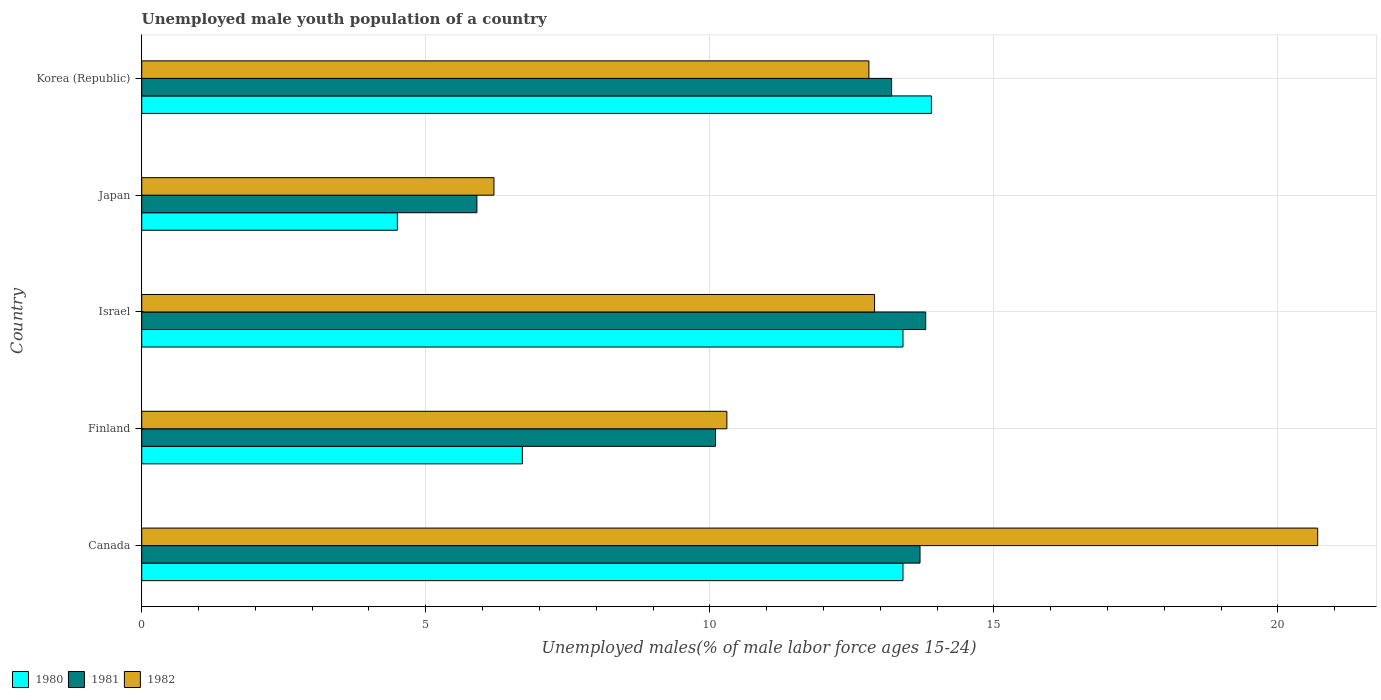How many different coloured bars are there?
Your response must be concise. 3. How many groups of bars are there?
Offer a terse response. 5. Are the number of bars on each tick of the Y-axis equal?
Offer a terse response. Yes. What is the label of the 4th group of bars from the top?
Provide a succinct answer. Finland. What is the percentage of unemployed male youth population in 1980 in Japan?
Your response must be concise. 4.5. Across all countries, what is the maximum percentage of unemployed male youth population in 1981?
Keep it short and to the point. 13.8. Across all countries, what is the minimum percentage of unemployed male youth population in 1982?
Your response must be concise. 6.2. In which country was the percentage of unemployed male youth population in 1982 minimum?
Your answer should be compact. Japan. What is the total percentage of unemployed male youth population in 1980 in the graph?
Your answer should be very brief. 51.9. What is the difference between the percentage of unemployed male youth population in 1982 in Canada and that in Korea (Republic)?
Your answer should be compact. 7.9. What is the difference between the percentage of unemployed male youth population in 1982 in Japan and the percentage of unemployed male youth population in 1981 in Canada?
Offer a terse response. -7.5. What is the average percentage of unemployed male youth population in 1982 per country?
Provide a short and direct response. 12.58. What is the difference between the percentage of unemployed male youth population in 1981 and percentage of unemployed male youth population in 1980 in Canada?
Keep it short and to the point. 0.3. What is the ratio of the percentage of unemployed male youth population in 1981 in Canada to that in Japan?
Provide a short and direct response. 2.32. Is the percentage of unemployed male youth population in 1981 in Finland less than that in Korea (Republic)?
Make the answer very short. Yes. What is the difference between the highest and the second highest percentage of unemployed male youth population in 1982?
Offer a terse response. 7.8. What is the difference between the highest and the lowest percentage of unemployed male youth population in 1981?
Offer a terse response. 7.9. What does the 2nd bar from the top in Israel represents?
Give a very brief answer. 1981. What does the 3rd bar from the bottom in Canada represents?
Your answer should be very brief. 1982. How many bars are there?
Keep it short and to the point. 15. Are all the bars in the graph horizontal?
Your answer should be very brief. Yes. Are the values on the major ticks of X-axis written in scientific E-notation?
Ensure brevity in your answer.  No. Does the graph contain any zero values?
Offer a very short reply. No. What is the title of the graph?
Keep it short and to the point. Unemployed male youth population of a country. What is the label or title of the X-axis?
Make the answer very short. Unemployed males(% of male labor force ages 15-24). What is the Unemployed males(% of male labor force ages 15-24) in 1980 in Canada?
Keep it short and to the point. 13.4. What is the Unemployed males(% of male labor force ages 15-24) of 1981 in Canada?
Offer a very short reply. 13.7. What is the Unemployed males(% of male labor force ages 15-24) of 1982 in Canada?
Your answer should be compact. 20.7. What is the Unemployed males(% of male labor force ages 15-24) of 1980 in Finland?
Your answer should be very brief. 6.7. What is the Unemployed males(% of male labor force ages 15-24) in 1981 in Finland?
Make the answer very short. 10.1. What is the Unemployed males(% of male labor force ages 15-24) in 1982 in Finland?
Give a very brief answer. 10.3. What is the Unemployed males(% of male labor force ages 15-24) of 1980 in Israel?
Provide a succinct answer. 13.4. What is the Unemployed males(% of male labor force ages 15-24) in 1981 in Israel?
Keep it short and to the point. 13.8. What is the Unemployed males(% of male labor force ages 15-24) of 1982 in Israel?
Keep it short and to the point. 12.9. What is the Unemployed males(% of male labor force ages 15-24) of 1981 in Japan?
Make the answer very short. 5.9. What is the Unemployed males(% of male labor force ages 15-24) of 1982 in Japan?
Provide a succinct answer. 6.2. What is the Unemployed males(% of male labor force ages 15-24) in 1980 in Korea (Republic)?
Your answer should be compact. 13.9. What is the Unemployed males(% of male labor force ages 15-24) of 1981 in Korea (Republic)?
Ensure brevity in your answer.  13.2. What is the Unemployed males(% of male labor force ages 15-24) in 1982 in Korea (Republic)?
Provide a short and direct response. 12.8. Across all countries, what is the maximum Unemployed males(% of male labor force ages 15-24) of 1980?
Your response must be concise. 13.9. Across all countries, what is the maximum Unemployed males(% of male labor force ages 15-24) in 1981?
Provide a short and direct response. 13.8. Across all countries, what is the maximum Unemployed males(% of male labor force ages 15-24) of 1982?
Ensure brevity in your answer.  20.7. Across all countries, what is the minimum Unemployed males(% of male labor force ages 15-24) in 1981?
Give a very brief answer. 5.9. Across all countries, what is the minimum Unemployed males(% of male labor force ages 15-24) in 1982?
Ensure brevity in your answer.  6.2. What is the total Unemployed males(% of male labor force ages 15-24) of 1980 in the graph?
Keep it short and to the point. 51.9. What is the total Unemployed males(% of male labor force ages 15-24) of 1981 in the graph?
Ensure brevity in your answer.  56.7. What is the total Unemployed males(% of male labor force ages 15-24) of 1982 in the graph?
Your response must be concise. 62.9. What is the difference between the Unemployed males(% of male labor force ages 15-24) of 1980 in Canada and that in Finland?
Your answer should be very brief. 6.7. What is the difference between the Unemployed males(% of male labor force ages 15-24) in 1982 in Canada and that in Finland?
Make the answer very short. 10.4. What is the difference between the Unemployed males(% of male labor force ages 15-24) in 1981 in Canada and that in Israel?
Keep it short and to the point. -0.1. What is the difference between the Unemployed males(% of male labor force ages 15-24) in 1982 in Canada and that in Israel?
Your answer should be compact. 7.8. What is the difference between the Unemployed males(% of male labor force ages 15-24) in 1981 in Canada and that in Japan?
Your answer should be compact. 7.8. What is the difference between the Unemployed males(% of male labor force ages 15-24) in 1982 in Canada and that in Japan?
Your response must be concise. 14.5. What is the difference between the Unemployed males(% of male labor force ages 15-24) in 1980 in Finland and that in Israel?
Make the answer very short. -6.7. What is the difference between the Unemployed males(% of male labor force ages 15-24) of 1981 in Finland and that in Israel?
Provide a short and direct response. -3.7. What is the difference between the Unemployed males(% of male labor force ages 15-24) of 1980 in Finland and that in Japan?
Give a very brief answer. 2.2. What is the difference between the Unemployed males(% of male labor force ages 15-24) in 1981 in Finland and that in Japan?
Provide a short and direct response. 4.2. What is the difference between the Unemployed males(% of male labor force ages 15-24) in 1982 in Finland and that in Japan?
Offer a very short reply. 4.1. What is the difference between the Unemployed males(% of male labor force ages 15-24) in 1980 in Finland and that in Korea (Republic)?
Provide a succinct answer. -7.2. What is the difference between the Unemployed males(% of male labor force ages 15-24) of 1980 in Israel and that in Japan?
Ensure brevity in your answer.  8.9. What is the difference between the Unemployed males(% of male labor force ages 15-24) in 1981 in Israel and that in Japan?
Offer a very short reply. 7.9. What is the difference between the Unemployed males(% of male labor force ages 15-24) in 1982 in Israel and that in Japan?
Your answer should be very brief. 6.7. What is the difference between the Unemployed males(% of male labor force ages 15-24) of 1982 in Israel and that in Korea (Republic)?
Offer a terse response. 0.1. What is the difference between the Unemployed males(% of male labor force ages 15-24) in 1980 in Japan and that in Korea (Republic)?
Ensure brevity in your answer.  -9.4. What is the difference between the Unemployed males(% of male labor force ages 15-24) of 1982 in Japan and that in Korea (Republic)?
Make the answer very short. -6.6. What is the difference between the Unemployed males(% of male labor force ages 15-24) of 1980 in Canada and the Unemployed males(% of male labor force ages 15-24) of 1982 in Finland?
Your response must be concise. 3.1. What is the difference between the Unemployed males(% of male labor force ages 15-24) in 1981 in Canada and the Unemployed males(% of male labor force ages 15-24) in 1982 in Finland?
Ensure brevity in your answer.  3.4. What is the difference between the Unemployed males(% of male labor force ages 15-24) of 1980 in Canada and the Unemployed males(% of male labor force ages 15-24) of 1981 in Israel?
Offer a terse response. -0.4. What is the difference between the Unemployed males(% of male labor force ages 15-24) of 1981 in Canada and the Unemployed males(% of male labor force ages 15-24) of 1982 in Israel?
Your answer should be very brief. 0.8. What is the difference between the Unemployed males(% of male labor force ages 15-24) in 1980 in Canada and the Unemployed males(% of male labor force ages 15-24) in 1981 in Japan?
Provide a short and direct response. 7.5. What is the difference between the Unemployed males(% of male labor force ages 15-24) in 1980 in Canada and the Unemployed males(% of male labor force ages 15-24) in 1982 in Japan?
Make the answer very short. 7.2. What is the difference between the Unemployed males(% of male labor force ages 15-24) in 1980 in Canada and the Unemployed males(% of male labor force ages 15-24) in 1981 in Korea (Republic)?
Provide a succinct answer. 0.2. What is the difference between the Unemployed males(% of male labor force ages 15-24) of 1980 in Canada and the Unemployed males(% of male labor force ages 15-24) of 1982 in Korea (Republic)?
Ensure brevity in your answer.  0.6. What is the difference between the Unemployed males(% of male labor force ages 15-24) in 1981 in Canada and the Unemployed males(% of male labor force ages 15-24) in 1982 in Korea (Republic)?
Your answer should be very brief. 0.9. What is the difference between the Unemployed males(% of male labor force ages 15-24) in 1980 in Finland and the Unemployed males(% of male labor force ages 15-24) in 1981 in Japan?
Make the answer very short. 0.8. What is the difference between the Unemployed males(% of male labor force ages 15-24) of 1980 in Finland and the Unemployed males(% of male labor force ages 15-24) of 1982 in Japan?
Provide a succinct answer. 0.5. What is the difference between the Unemployed males(% of male labor force ages 15-24) of 1981 in Finland and the Unemployed males(% of male labor force ages 15-24) of 1982 in Japan?
Your response must be concise. 3.9. What is the difference between the Unemployed males(% of male labor force ages 15-24) of 1980 in Finland and the Unemployed males(% of male labor force ages 15-24) of 1981 in Korea (Republic)?
Give a very brief answer. -6.5. What is the difference between the Unemployed males(% of male labor force ages 15-24) in 1980 in Israel and the Unemployed males(% of male labor force ages 15-24) in 1981 in Japan?
Ensure brevity in your answer.  7.5. What is the difference between the Unemployed males(% of male labor force ages 15-24) of 1980 in Israel and the Unemployed males(% of male labor force ages 15-24) of 1981 in Korea (Republic)?
Keep it short and to the point. 0.2. What is the difference between the Unemployed males(% of male labor force ages 15-24) in 1980 in Israel and the Unemployed males(% of male labor force ages 15-24) in 1982 in Korea (Republic)?
Your response must be concise. 0.6. What is the difference between the Unemployed males(% of male labor force ages 15-24) in 1980 in Japan and the Unemployed males(% of male labor force ages 15-24) in 1981 in Korea (Republic)?
Offer a terse response. -8.7. What is the difference between the Unemployed males(% of male labor force ages 15-24) in 1980 in Japan and the Unemployed males(% of male labor force ages 15-24) in 1982 in Korea (Republic)?
Provide a succinct answer. -8.3. What is the average Unemployed males(% of male labor force ages 15-24) of 1980 per country?
Offer a terse response. 10.38. What is the average Unemployed males(% of male labor force ages 15-24) of 1981 per country?
Your answer should be compact. 11.34. What is the average Unemployed males(% of male labor force ages 15-24) of 1982 per country?
Your answer should be compact. 12.58. What is the difference between the Unemployed males(% of male labor force ages 15-24) of 1980 and Unemployed males(% of male labor force ages 15-24) of 1981 in Canada?
Your response must be concise. -0.3. What is the difference between the Unemployed males(% of male labor force ages 15-24) of 1980 and Unemployed males(% of male labor force ages 15-24) of 1982 in Canada?
Make the answer very short. -7.3. What is the difference between the Unemployed males(% of male labor force ages 15-24) of 1980 and Unemployed males(% of male labor force ages 15-24) of 1981 in Finland?
Provide a succinct answer. -3.4. What is the difference between the Unemployed males(% of male labor force ages 15-24) of 1980 and Unemployed males(% of male labor force ages 15-24) of 1982 in Finland?
Offer a terse response. -3.6. What is the difference between the Unemployed males(% of male labor force ages 15-24) in 1980 and Unemployed males(% of male labor force ages 15-24) in 1981 in Israel?
Offer a terse response. -0.4. What is the difference between the Unemployed males(% of male labor force ages 15-24) of 1981 and Unemployed males(% of male labor force ages 15-24) of 1982 in Israel?
Keep it short and to the point. 0.9. What is the difference between the Unemployed males(% of male labor force ages 15-24) of 1980 and Unemployed males(% of male labor force ages 15-24) of 1981 in Japan?
Your answer should be compact. -1.4. What is the difference between the Unemployed males(% of male labor force ages 15-24) in 1980 and Unemployed males(% of male labor force ages 15-24) in 1982 in Japan?
Offer a terse response. -1.7. What is the difference between the Unemployed males(% of male labor force ages 15-24) in 1980 and Unemployed males(% of male labor force ages 15-24) in 1981 in Korea (Republic)?
Provide a succinct answer. 0.7. What is the difference between the Unemployed males(% of male labor force ages 15-24) in 1980 and Unemployed males(% of male labor force ages 15-24) in 1982 in Korea (Republic)?
Provide a succinct answer. 1.1. What is the difference between the Unemployed males(% of male labor force ages 15-24) of 1981 and Unemployed males(% of male labor force ages 15-24) of 1982 in Korea (Republic)?
Keep it short and to the point. 0.4. What is the ratio of the Unemployed males(% of male labor force ages 15-24) of 1980 in Canada to that in Finland?
Your answer should be very brief. 2. What is the ratio of the Unemployed males(% of male labor force ages 15-24) of 1981 in Canada to that in Finland?
Your answer should be compact. 1.36. What is the ratio of the Unemployed males(% of male labor force ages 15-24) of 1982 in Canada to that in Finland?
Your answer should be compact. 2.01. What is the ratio of the Unemployed males(% of male labor force ages 15-24) in 1981 in Canada to that in Israel?
Provide a succinct answer. 0.99. What is the ratio of the Unemployed males(% of male labor force ages 15-24) in 1982 in Canada to that in Israel?
Give a very brief answer. 1.6. What is the ratio of the Unemployed males(% of male labor force ages 15-24) in 1980 in Canada to that in Japan?
Your response must be concise. 2.98. What is the ratio of the Unemployed males(% of male labor force ages 15-24) of 1981 in Canada to that in Japan?
Offer a terse response. 2.32. What is the ratio of the Unemployed males(% of male labor force ages 15-24) in 1982 in Canada to that in Japan?
Ensure brevity in your answer.  3.34. What is the ratio of the Unemployed males(% of male labor force ages 15-24) of 1980 in Canada to that in Korea (Republic)?
Provide a succinct answer. 0.96. What is the ratio of the Unemployed males(% of male labor force ages 15-24) of 1981 in Canada to that in Korea (Republic)?
Your response must be concise. 1.04. What is the ratio of the Unemployed males(% of male labor force ages 15-24) of 1982 in Canada to that in Korea (Republic)?
Your answer should be compact. 1.62. What is the ratio of the Unemployed males(% of male labor force ages 15-24) in 1981 in Finland to that in Israel?
Give a very brief answer. 0.73. What is the ratio of the Unemployed males(% of male labor force ages 15-24) in 1982 in Finland to that in Israel?
Make the answer very short. 0.8. What is the ratio of the Unemployed males(% of male labor force ages 15-24) of 1980 in Finland to that in Japan?
Provide a succinct answer. 1.49. What is the ratio of the Unemployed males(% of male labor force ages 15-24) of 1981 in Finland to that in Japan?
Your response must be concise. 1.71. What is the ratio of the Unemployed males(% of male labor force ages 15-24) of 1982 in Finland to that in Japan?
Ensure brevity in your answer.  1.66. What is the ratio of the Unemployed males(% of male labor force ages 15-24) in 1980 in Finland to that in Korea (Republic)?
Your response must be concise. 0.48. What is the ratio of the Unemployed males(% of male labor force ages 15-24) of 1981 in Finland to that in Korea (Republic)?
Your answer should be very brief. 0.77. What is the ratio of the Unemployed males(% of male labor force ages 15-24) of 1982 in Finland to that in Korea (Republic)?
Provide a short and direct response. 0.8. What is the ratio of the Unemployed males(% of male labor force ages 15-24) in 1980 in Israel to that in Japan?
Provide a succinct answer. 2.98. What is the ratio of the Unemployed males(% of male labor force ages 15-24) of 1981 in Israel to that in Japan?
Your response must be concise. 2.34. What is the ratio of the Unemployed males(% of male labor force ages 15-24) in 1982 in Israel to that in Japan?
Your answer should be very brief. 2.08. What is the ratio of the Unemployed males(% of male labor force ages 15-24) in 1981 in Israel to that in Korea (Republic)?
Keep it short and to the point. 1.05. What is the ratio of the Unemployed males(% of male labor force ages 15-24) in 1982 in Israel to that in Korea (Republic)?
Offer a very short reply. 1.01. What is the ratio of the Unemployed males(% of male labor force ages 15-24) in 1980 in Japan to that in Korea (Republic)?
Provide a short and direct response. 0.32. What is the ratio of the Unemployed males(% of male labor force ages 15-24) of 1981 in Japan to that in Korea (Republic)?
Offer a very short reply. 0.45. What is the ratio of the Unemployed males(% of male labor force ages 15-24) of 1982 in Japan to that in Korea (Republic)?
Your response must be concise. 0.48. What is the difference between the highest and the second highest Unemployed males(% of male labor force ages 15-24) of 1981?
Provide a short and direct response. 0.1. What is the difference between the highest and the lowest Unemployed males(% of male labor force ages 15-24) of 1980?
Your response must be concise. 9.4. What is the difference between the highest and the lowest Unemployed males(% of male labor force ages 15-24) in 1981?
Keep it short and to the point. 7.9. What is the difference between the highest and the lowest Unemployed males(% of male labor force ages 15-24) of 1982?
Make the answer very short. 14.5. 